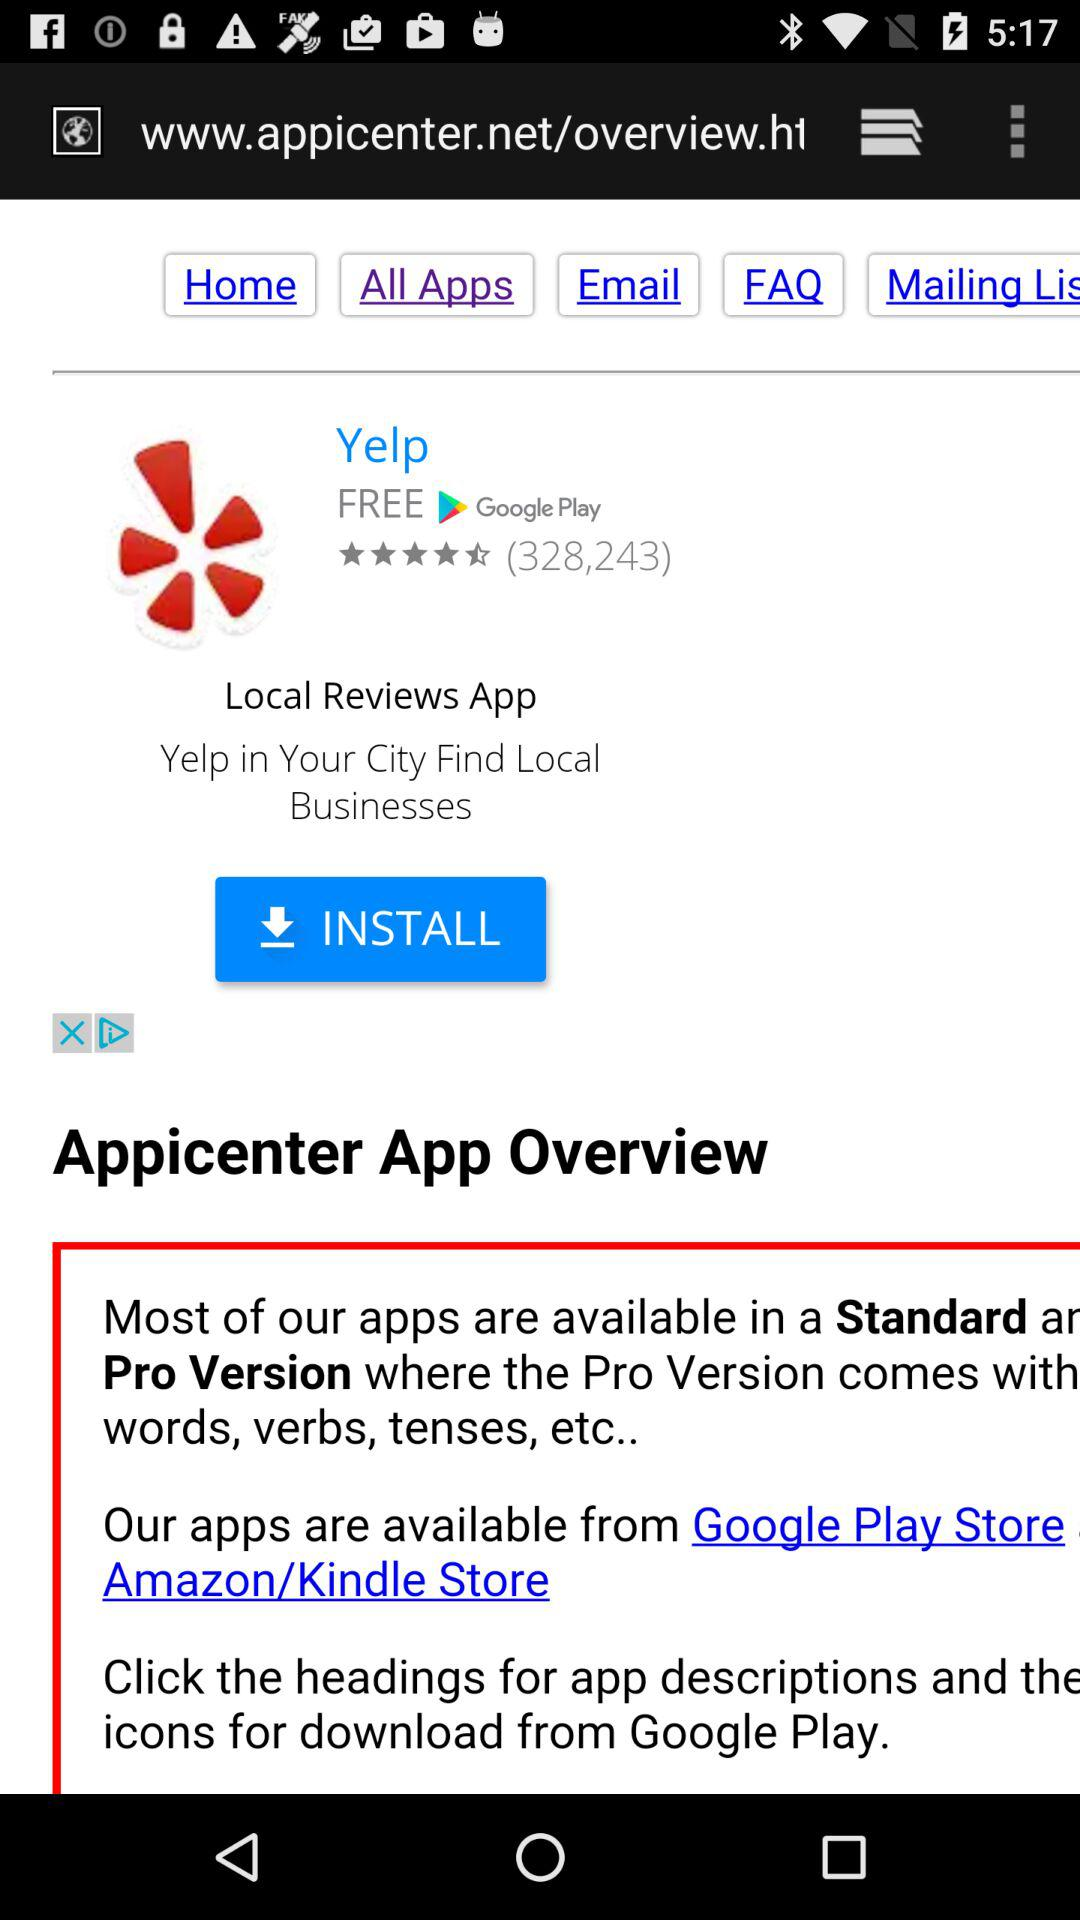How many rating stars are there? There are 4.5 stars. 